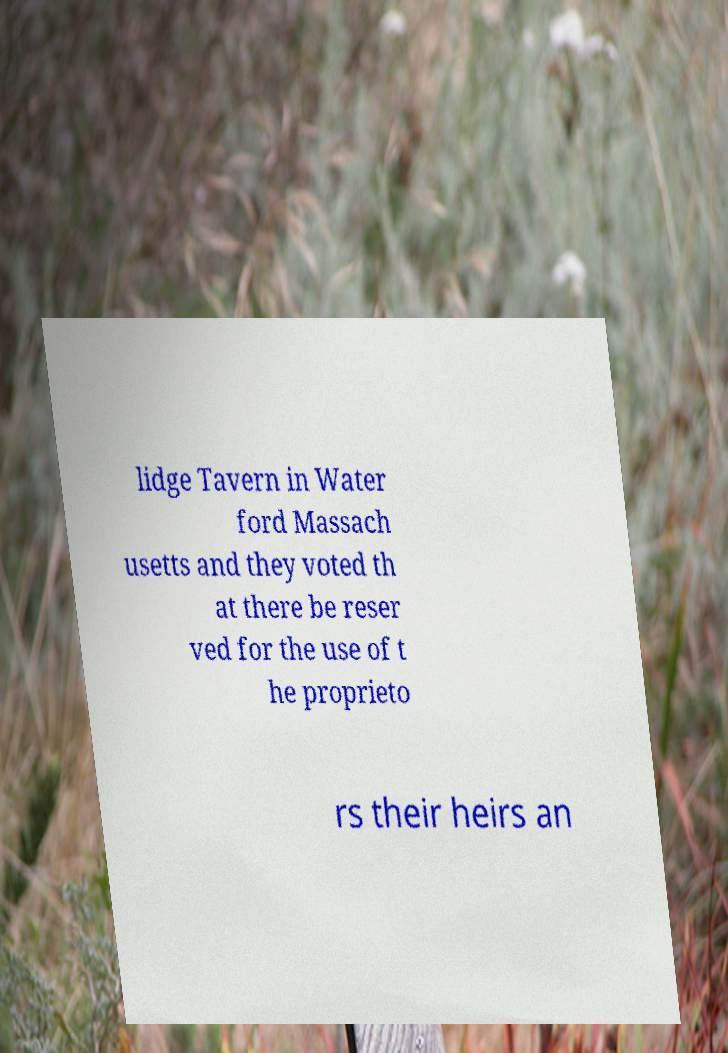Please identify and transcribe the text found in this image. lidge Tavern in Water ford Massach usetts and they voted th at there be reser ved for the use of t he proprieto rs their heirs an 